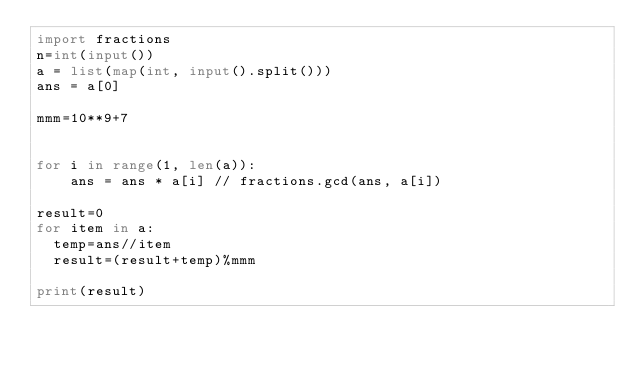Convert code to text. <code><loc_0><loc_0><loc_500><loc_500><_Python_>import fractions
n=int(input())
a = list(map(int, input().split()))
ans = a[0]

mmm=10**9+7
 

for i in range(1, len(a)):
    ans = ans * a[i] // fractions.gcd(ans, a[i])
    
result=0
for item in a:
  temp=ans//item
  result=(result+temp)%mmm
 
print(result)
</code> 